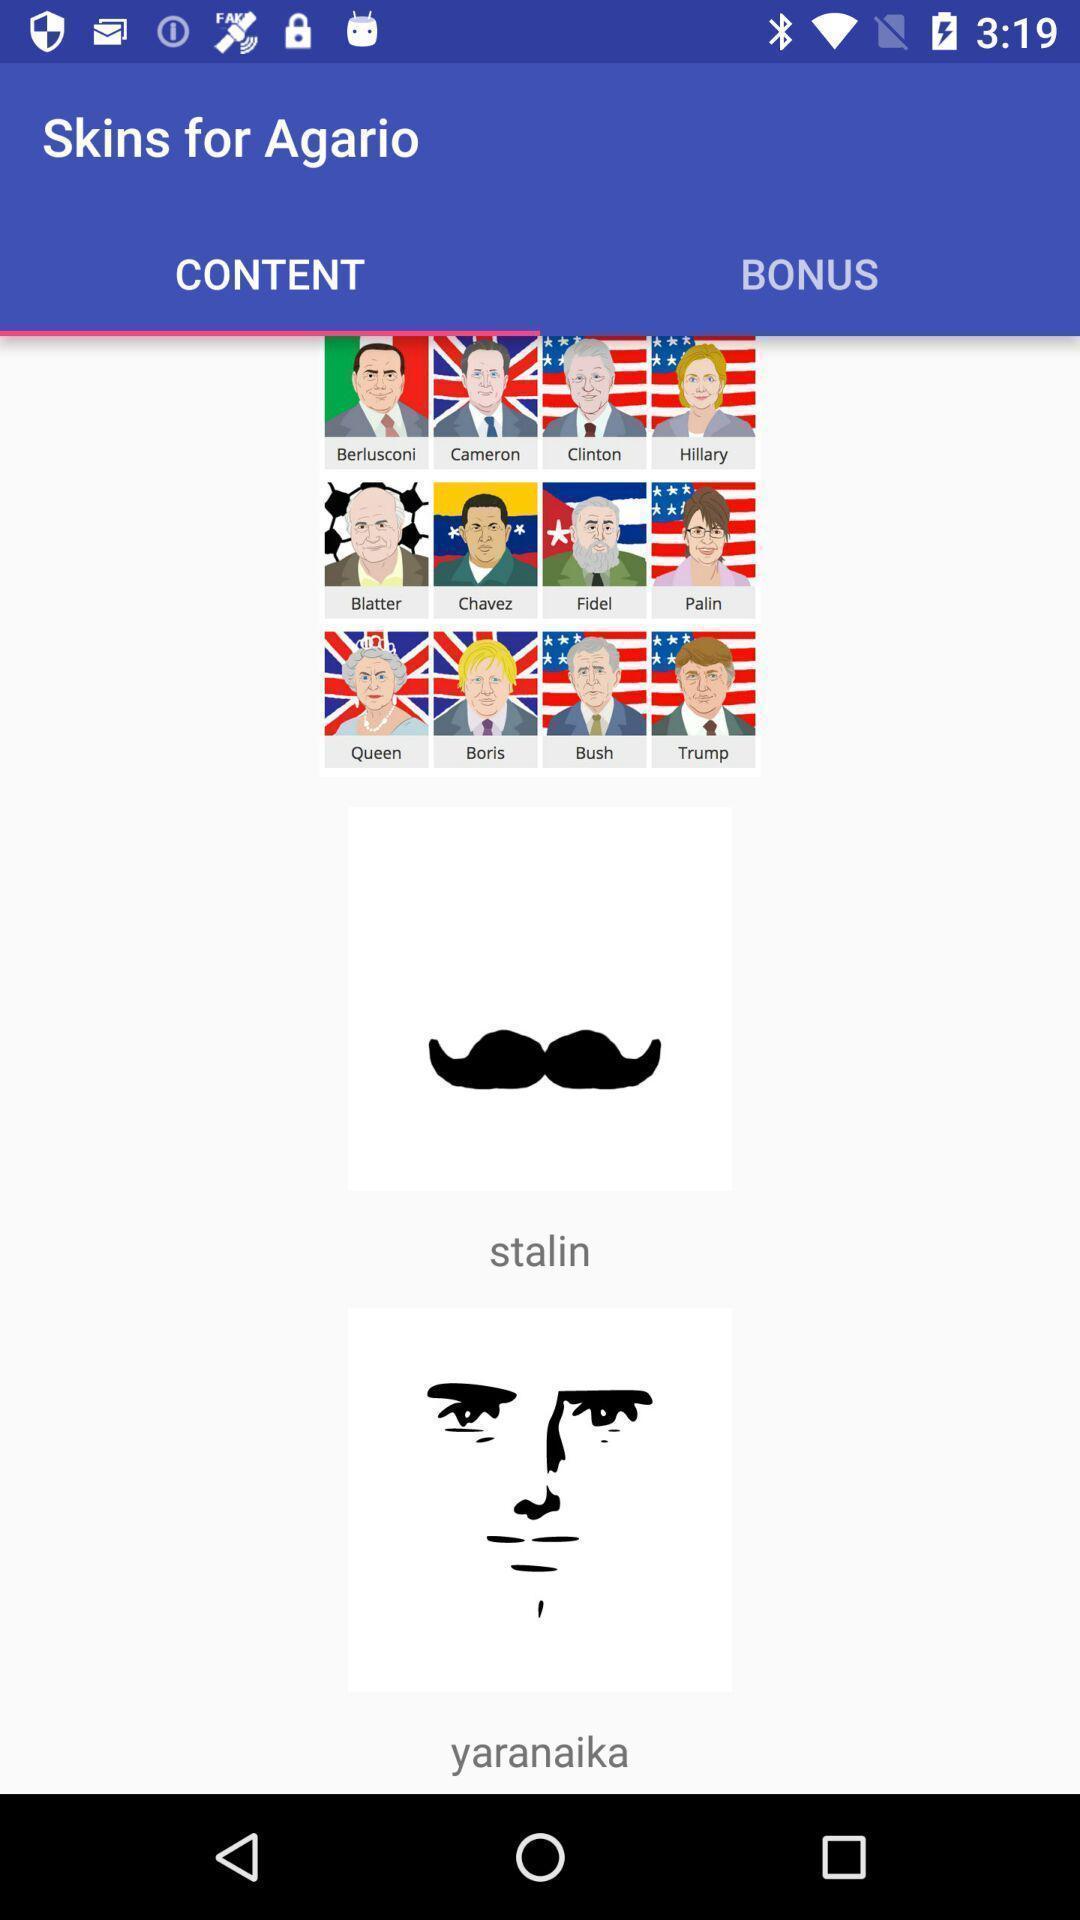Summarize the main components in this picture. Screen displaying content page. 